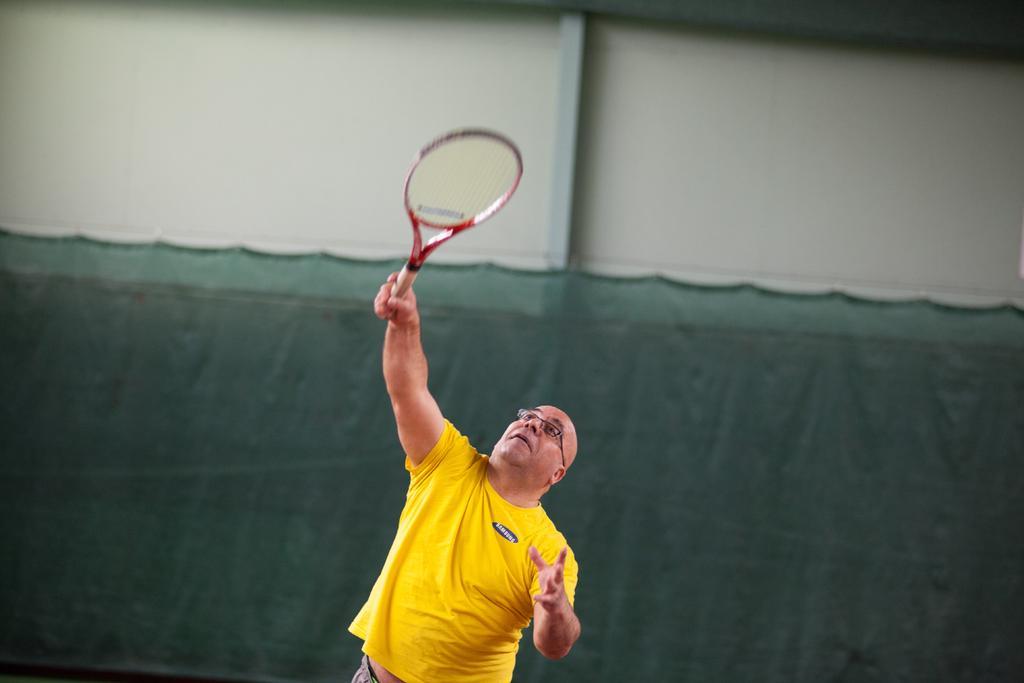Can you describe this image briefly? This is the man standing and holding a tennis racket in his hand. He wore a yellow T-shirt and a spectacle. In the background, that looks like a cloth hanging, which is green in color. This is the wall. 